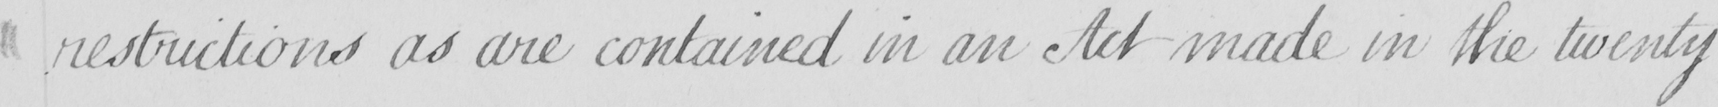Please provide the text content of this handwritten line. restrictions as are contained in an Act made in the twenty 